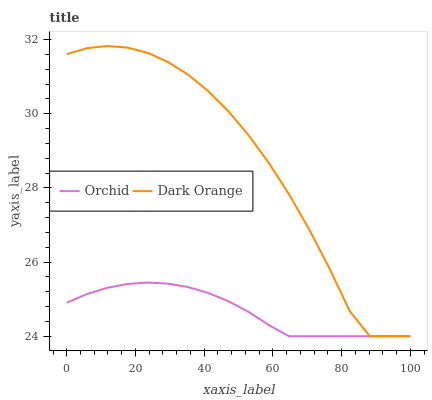Does Orchid have the minimum area under the curve?
Answer yes or no. Yes. Does Dark Orange have the maximum area under the curve?
Answer yes or no. Yes. Does Orchid have the maximum area under the curve?
Answer yes or no. No. Is Orchid the smoothest?
Answer yes or no. Yes. Is Dark Orange the roughest?
Answer yes or no. Yes. Is Orchid the roughest?
Answer yes or no. No. Does Dark Orange have the lowest value?
Answer yes or no. Yes. Does Dark Orange have the highest value?
Answer yes or no. Yes. Does Orchid have the highest value?
Answer yes or no. No. Does Dark Orange intersect Orchid?
Answer yes or no. Yes. Is Dark Orange less than Orchid?
Answer yes or no. No. Is Dark Orange greater than Orchid?
Answer yes or no. No. 